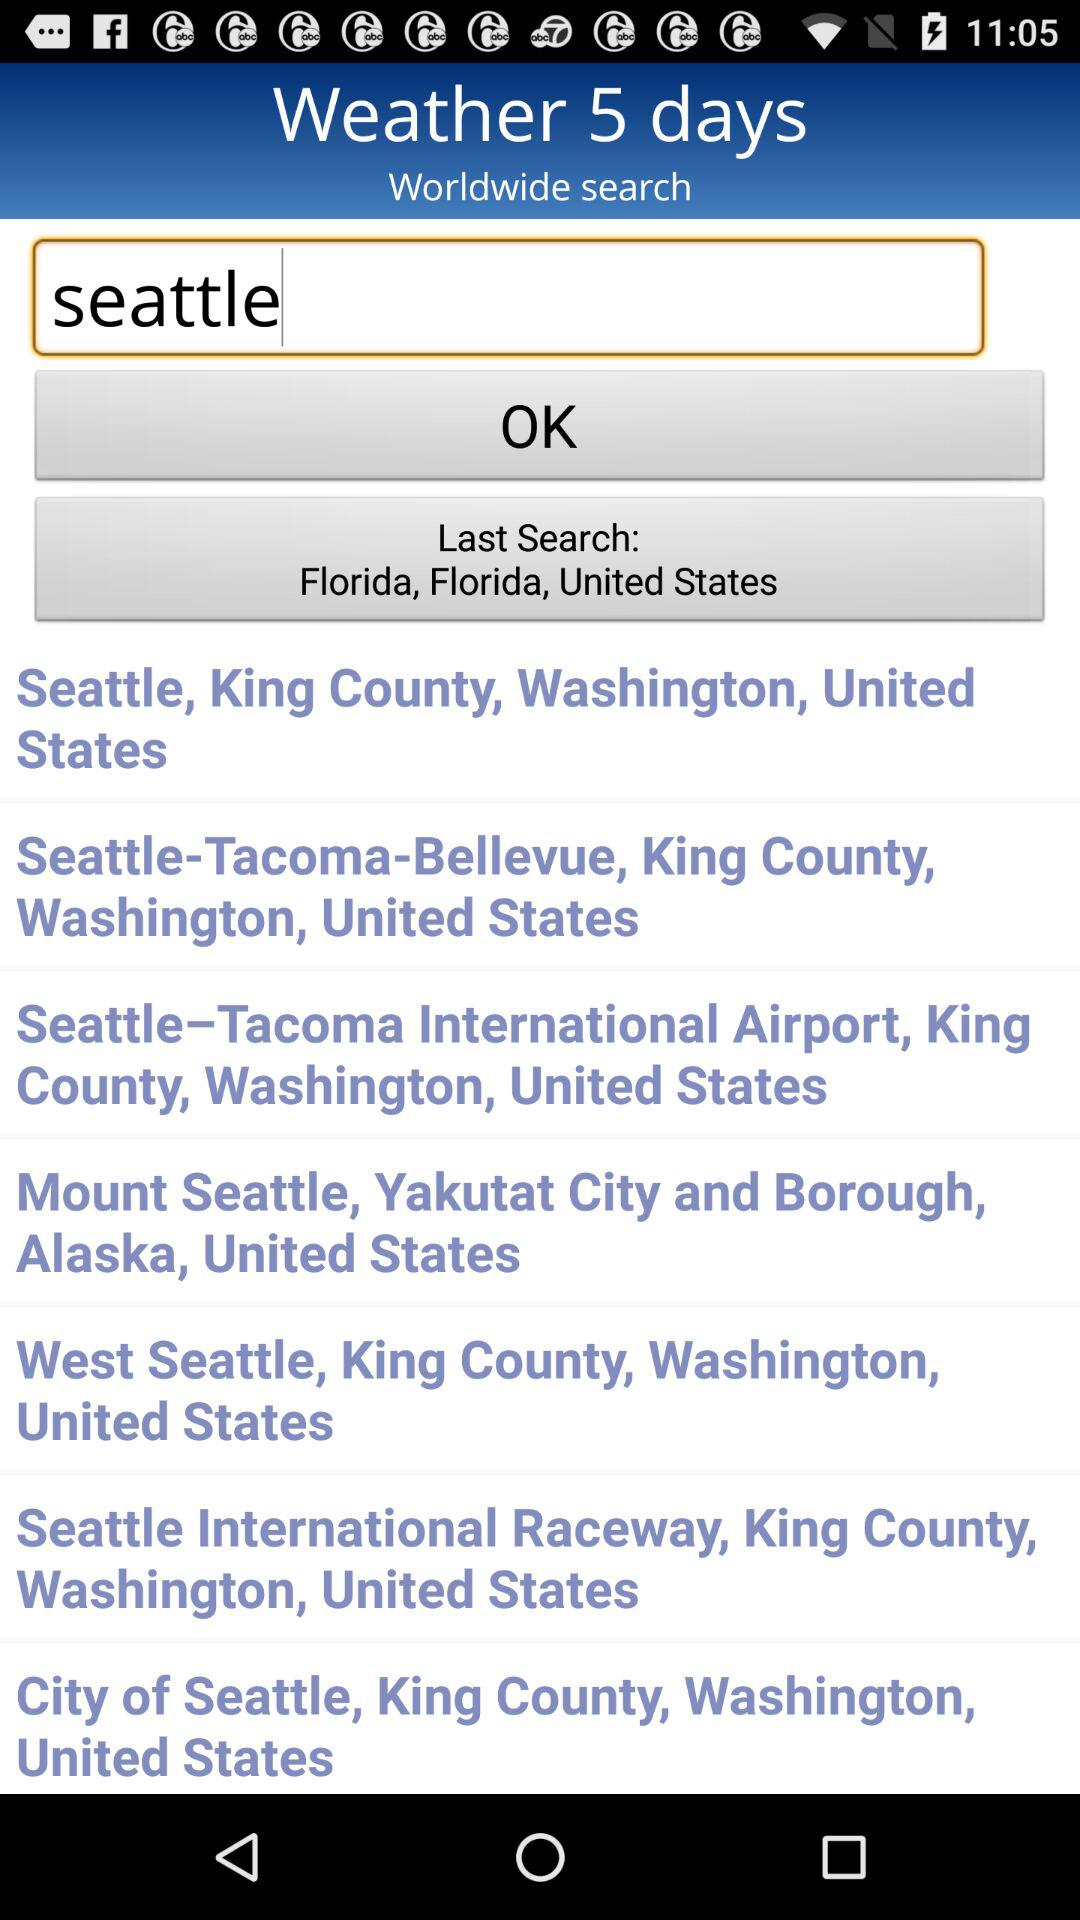What is the text entered in the search bar? The text entered in the search bar is "seattle". 